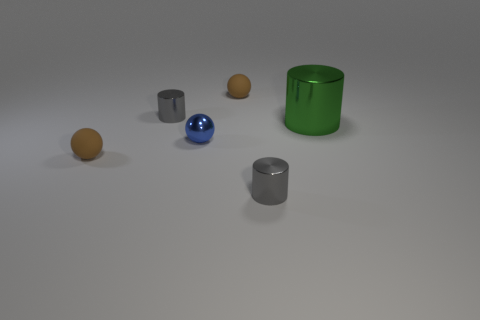What is the shape of the tiny matte thing right of the tiny brown matte thing in front of the small gray cylinder that is behind the large thing?
Keep it short and to the point. Sphere. There is a small gray thing in front of the tiny shiny sphere; is its shape the same as the tiny shiny thing behind the big green cylinder?
Provide a short and direct response. Yes. Are there any other things that have the same size as the green thing?
Keep it short and to the point. No. How many cylinders are large green objects or tiny matte objects?
Your response must be concise. 1. Do the blue object and the green thing have the same material?
Give a very brief answer. Yes. What number of other things are there of the same color as the big shiny object?
Ensure brevity in your answer.  0. What is the shape of the brown matte thing behind the green cylinder?
Ensure brevity in your answer.  Sphere. What number of objects are either small gray shiny balls or metal objects?
Make the answer very short. 4. Is the size of the green metal object the same as the gray cylinder behind the large metallic object?
Offer a very short reply. No. What number of other things are the same material as the big green cylinder?
Offer a very short reply. 3. 